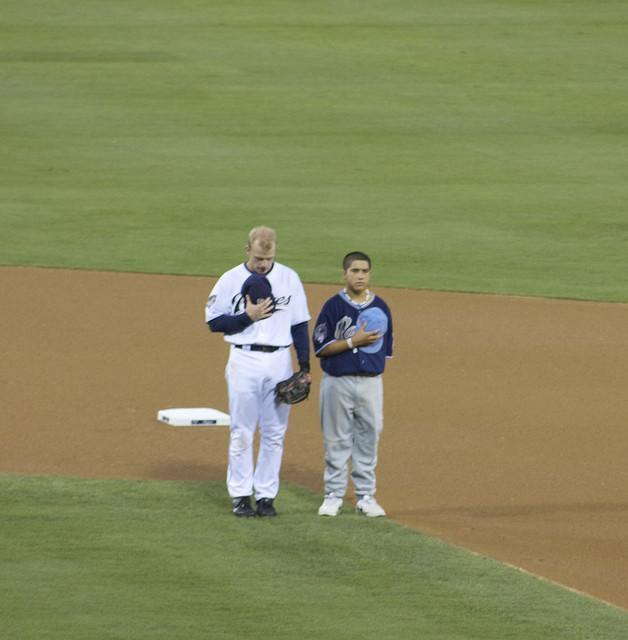How many people are there?
Give a very brief answer. 2. 